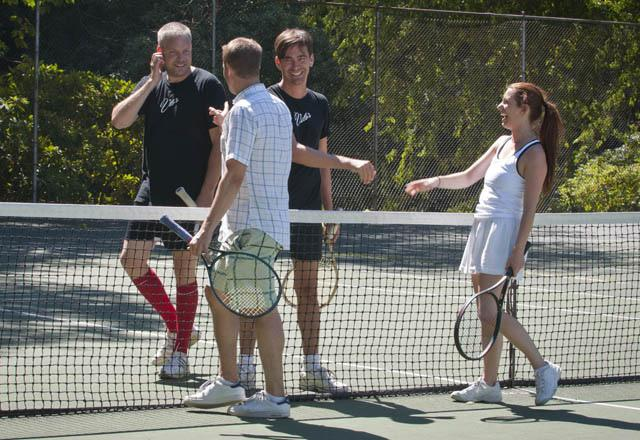How much farther can the red socks be pulled up normally? Please explain your reasoning. not much. They are almost to the knees 